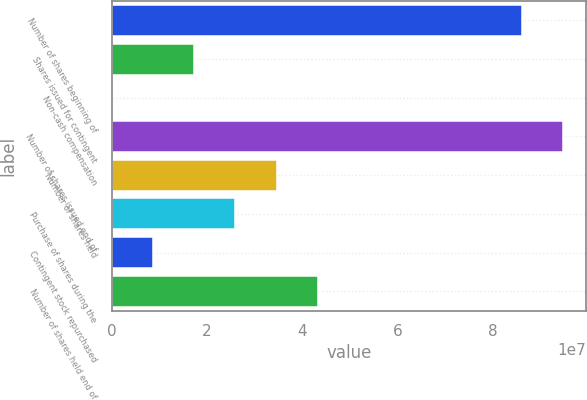Convert chart. <chart><loc_0><loc_0><loc_500><loc_500><bar_chart><fcel>Number of shares beginning of<fcel>Shares issued for contingent<fcel>Non-cash compensation<fcel>Number of shares issued end of<fcel>Number of shares held<fcel>Purchase of shares during the<fcel>Contingent stock repurchased<fcel>Number of shares held end of<nl><fcel>8.61427e+07<fcel>1.73018e+07<fcel>4983<fcel>9.47911e+07<fcel>3.45986e+07<fcel>2.59502e+07<fcel>8.65338e+06<fcel>4.32469e+07<nl></chart> 